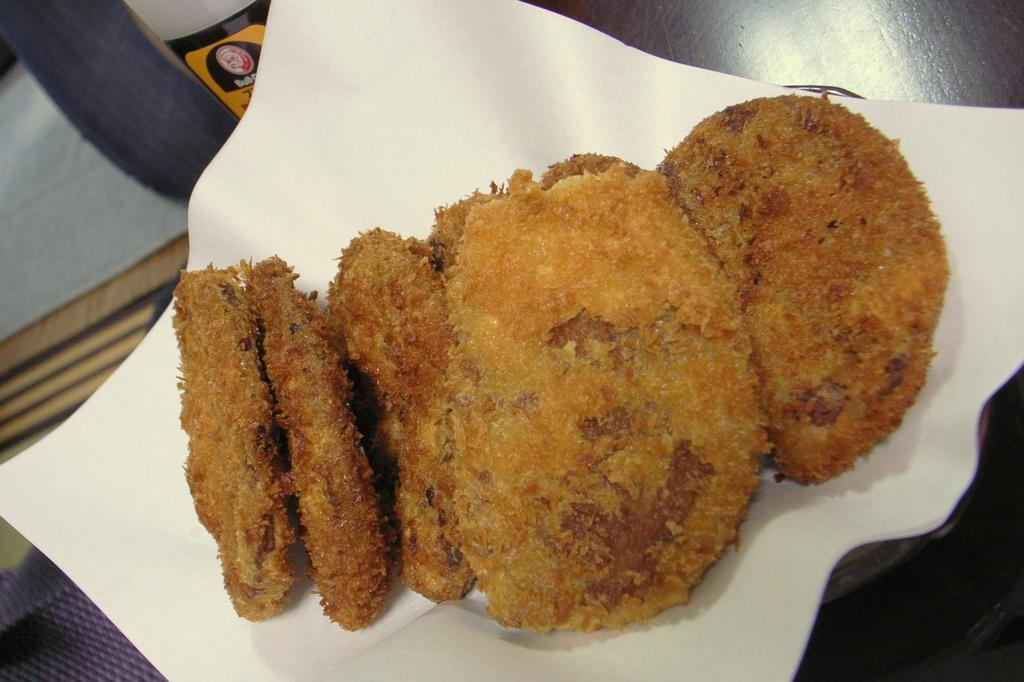What is the main subject of the image? The main subject of the image is food. Where is the food located in the image? The food is on a platform. What else is on the platform with the food? There is paper on the platform. Can you describe any other objects in the image? Yes, there are other objects in the image. What street is the deer crossing in the image? There is no street or deer present in the image. 